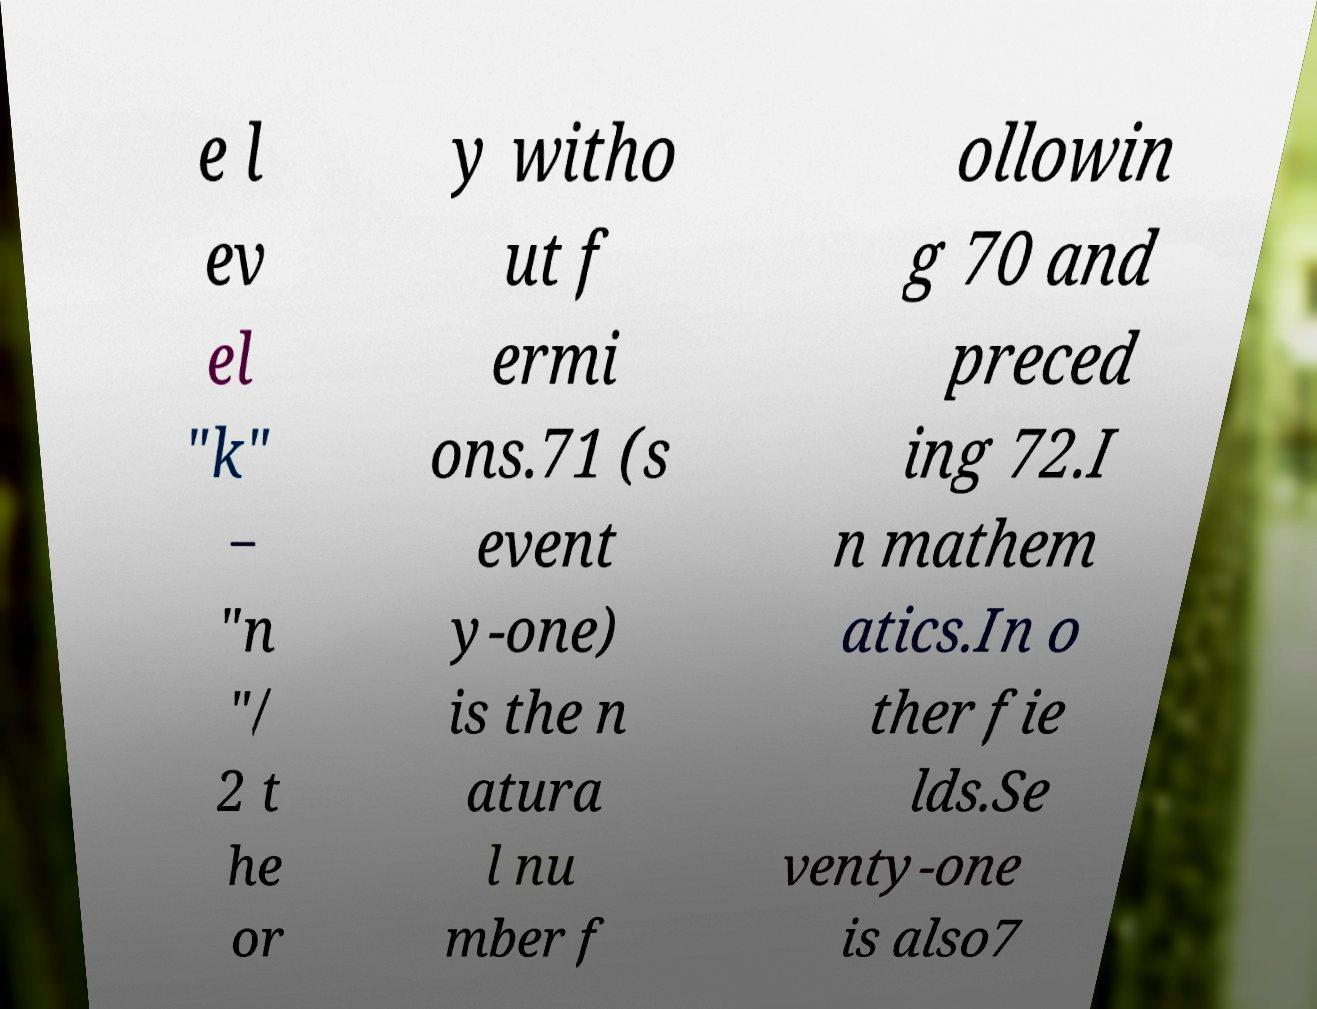For documentation purposes, I need the text within this image transcribed. Could you provide that? e l ev el "k" − "n "/ 2 t he or y witho ut f ermi ons.71 (s event y-one) is the n atura l nu mber f ollowin g 70 and preced ing 72.I n mathem atics.In o ther fie lds.Se venty-one is also7 